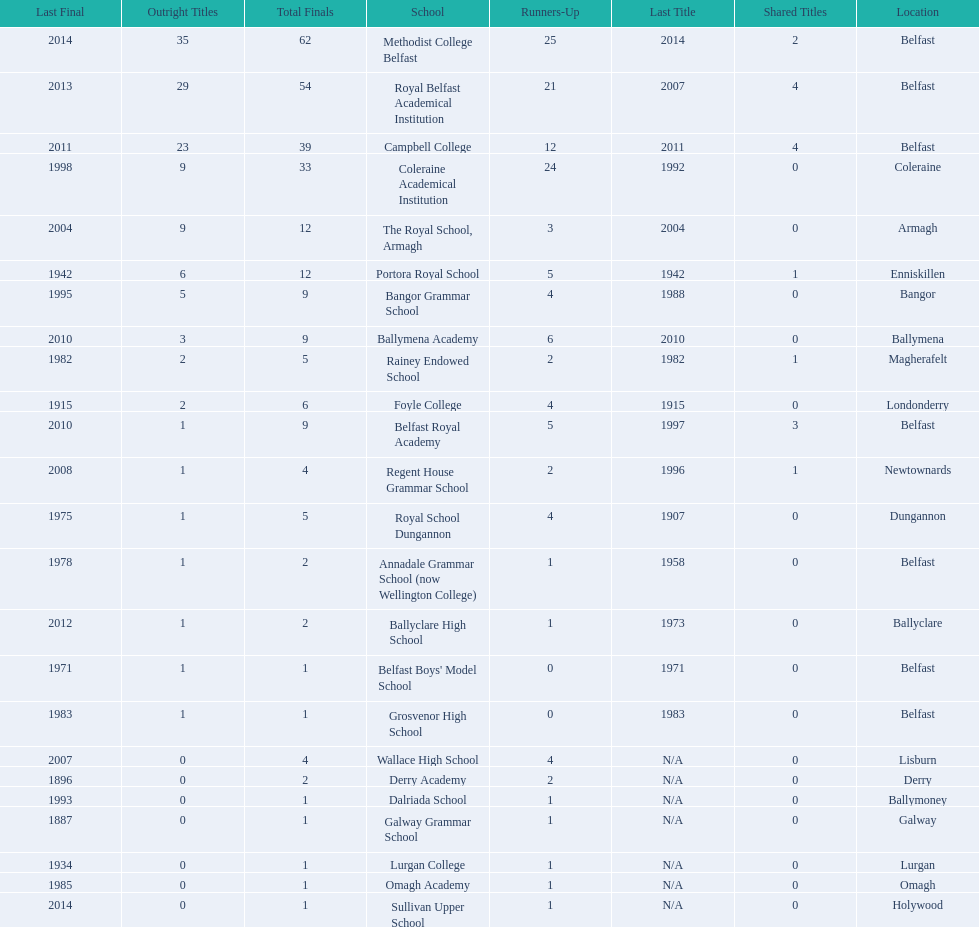Which colleges participated in the ulster's schools' cup? Methodist College Belfast, Royal Belfast Academical Institution, Campbell College, Coleraine Academical Institution, The Royal School, Armagh, Portora Royal School, Bangor Grammar School, Ballymena Academy, Rainey Endowed School, Foyle College, Belfast Royal Academy, Regent House Grammar School, Royal School Dungannon, Annadale Grammar School (now Wellington College), Ballyclare High School, Belfast Boys' Model School, Grosvenor High School, Wallace High School, Derry Academy, Dalriada School, Galway Grammar School, Lurgan College, Omagh Academy, Sullivan Upper School. Of these, which are from belfast? Methodist College Belfast, Royal Belfast Academical Institution, Campbell College, Belfast Royal Academy, Annadale Grammar School (now Wellington College), Belfast Boys' Model School, Grosvenor High School. Of these, which have more than 20 outright titles? Methodist College Belfast, Royal Belfast Academical Institution, Campbell College. Which of these have the fewest runners-up? Campbell College. 